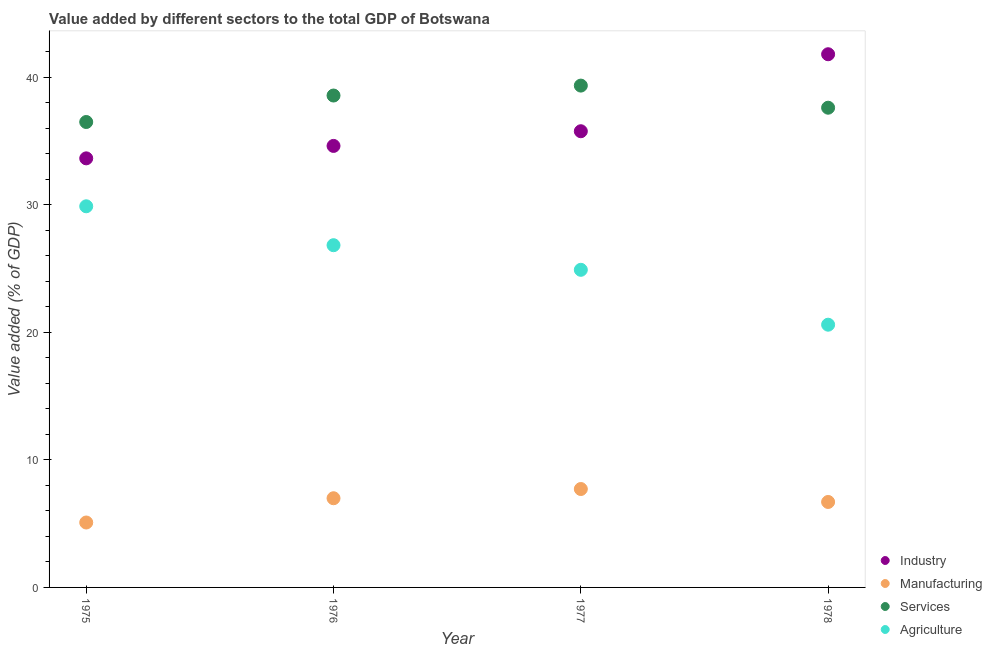How many different coloured dotlines are there?
Keep it short and to the point. 4. What is the value added by services sector in 1976?
Your answer should be compact. 38.56. Across all years, what is the maximum value added by industrial sector?
Provide a short and direct response. 41.8. Across all years, what is the minimum value added by manufacturing sector?
Provide a short and direct response. 5.09. In which year was the value added by industrial sector maximum?
Give a very brief answer. 1978. In which year was the value added by agricultural sector minimum?
Keep it short and to the point. 1978. What is the total value added by industrial sector in the graph?
Your answer should be very brief. 145.81. What is the difference between the value added by manufacturing sector in 1977 and that in 1978?
Keep it short and to the point. 1.01. What is the difference between the value added by services sector in 1975 and the value added by manufacturing sector in 1977?
Give a very brief answer. 28.77. What is the average value added by manufacturing sector per year?
Make the answer very short. 6.62. In the year 1975, what is the difference between the value added by services sector and value added by manufacturing sector?
Your answer should be compact. 31.4. In how many years, is the value added by agricultural sector greater than 22 %?
Ensure brevity in your answer.  3. What is the ratio of the value added by services sector in 1975 to that in 1977?
Your answer should be very brief. 0.93. Is the value added by industrial sector in 1975 less than that in 1977?
Make the answer very short. Yes. What is the difference between the highest and the second highest value added by manufacturing sector?
Provide a succinct answer. 0.72. What is the difference between the highest and the lowest value added by services sector?
Keep it short and to the point. 2.85. Is the sum of the value added by manufacturing sector in 1975 and 1977 greater than the maximum value added by industrial sector across all years?
Offer a very short reply. No. Is it the case that in every year, the sum of the value added by industrial sector and value added by services sector is greater than the sum of value added by manufacturing sector and value added by agricultural sector?
Your answer should be very brief. No. Is it the case that in every year, the sum of the value added by industrial sector and value added by manufacturing sector is greater than the value added by services sector?
Offer a terse response. Yes. Does the value added by services sector monotonically increase over the years?
Provide a succinct answer. No. Is the value added by industrial sector strictly greater than the value added by agricultural sector over the years?
Give a very brief answer. Yes. Is the value added by manufacturing sector strictly less than the value added by services sector over the years?
Keep it short and to the point. Yes. Are the values on the major ticks of Y-axis written in scientific E-notation?
Your answer should be very brief. No. Does the graph contain any zero values?
Your response must be concise. No. How many legend labels are there?
Keep it short and to the point. 4. How are the legend labels stacked?
Offer a terse response. Vertical. What is the title of the graph?
Ensure brevity in your answer.  Value added by different sectors to the total GDP of Botswana. Does "Coal" appear as one of the legend labels in the graph?
Give a very brief answer. No. What is the label or title of the X-axis?
Give a very brief answer. Year. What is the label or title of the Y-axis?
Offer a very short reply. Value added (% of GDP). What is the Value added (% of GDP) of Industry in 1975?
Provide a succinct answer. 33.64. What is the Value added (% of GDP) in Manufacturing in 1975?
Your answer should be compact. 5.09. What is the Value added (% of GDP) in Services in 1975?
Your answer should be very brief. 36.49. What is the Value added (% of GDP) of Agriculture in 1975?
Offer a terse response. 29.88. What is the Value added (% of GDP) in Industry in 1976?
Give a very brief answer. 34.61. What is the Value added (% of GDP) in Manufacturing in 1976?
Ensure brevity in your answer.  6.99. What is the Value added (% of GDP) in Services in 1976?
Make the answer very short. 38.56. What is the Value added (% of GDP) of Agriculture in 1976?
Offer a very short reply. 26.83. What is the Value added (% of GDP) of Industry in 1977?
Keep it short and to the point. 35.76. What is the Value added (% of GDP) in Manufacturing in 1977?
Give a very brief answer. 7.71. What is the Value added (% of GDP) in Services in 1977?
Give a very brief answer. 39.34. What is the Value added (% of GDP) in Agriculture in 1977?
Ensure brevity in your answer.  24.9. What is the Value added (% of GDP) in Industry in 1978?
Your answer should be compact. 41.8. What is the Value added (% of GDP) of Manufacturing in 1978?
Provide a succinct answer. 6.7. What is the Value added (% of GDP) of Services in 1978?
Your response must be concise. 37.61. What is the Value added (% of GDP) in Agriculture in 1978?
Provide a succinct answer. 20.6. Across all years, what is the maximum Value added (% of GDP) of Industry?
Your answer should be very brief. 41.8. Across all years, what is the maximum Value added (% of GDP) of Manufacturing?
Your answer should be very brief. 7.71. Across all years, what is the maximum Value added (% of GDP) in Services?
Make the answer very short. 39.34. Across all years, what is the maximum Value added (% of GDP) of Agriculture?
Give a very brief answer. 29.88. Across all years, what is the minimum Value added (% of GDP) in Industry?
Your answer should be compact. 33.64. Across all years, what is the minimum Value added (% of GDP) in Manufacturing?
Your answer should be very brief. 5.09. Across all years, what is the minimum Value added (% of GDP) of Services?
Keep it short and to the point. 36.49. Across all years, what is the minimum Value added (% of GDP) in Agriculture?
Give a very brief answer. 20.6. What is the total Value added (% of GDP) in Industry in the graph?
Keep it short and to the point. 145.81. What is the total Value added (% of GDP) in Manufacturing in the graph?
Your response must be concise. 26.49. What is the total Value added (% of GDP) in Services in the graph?
Offer a terse response. 151.99. What is the total Value added (% of GDP) of Agriculture in the graph?
Offer a very short reply. 102.2. What is the difference between the Value added (% of GDP) in Industry in 1975 and that in 1976?
Offer a terse response. -0.97. What is the difference between the Value added (% of GDP) of Manufacturing in 1975 and that in 1976?
Provide a succinct answer. -1.9. What is the difference between the Value added (% of GDP) of Services in 1975 and that in 1976?
Ensure brevity in your answer.  -2.08. What is the difference between the Value added (% of GDP) in Agriculture in 1975 and that in 1976?
Make the answer very short. 3.05. What is the difference between the Value added (% of GDP) of Industry in 1975 and that in 1977?
Offer a terse response. -2.13. What is the difference between the Value added (% of GDP) of Manufacturing in 1975 and that in 1977?
Your response must be concise. -2.63. What is the difference between the Value added (% of GDP) in Services in 1975 and that in 1977?
Provide a succinct answer. -2.85. What is the difference between the Value added (% of GDP) in Agriculture in 1975 and that in 1977?
Ensure brevity in your answer.  4.98. What is the difference between the Value added (% of GDP) in Industry in 1975 and that in 1978?
Make the answer very short. -8.16. What is the difference between the Value added (% of GDP) in Manufacturing in 1975 and that in 1978?
Keep it short and to the point. -1.61. What is the difference between the Value added (% of GDP) in Services in 1975 and that in 1978?
Offer a terse response. -1.12. What is the difference between the Value added (% of GDP) of Agriculture in 1975 and that in 1978?
Offer a very short reply. 9.28. What is the difference between the Value added (% of GDP) in Industry in 1976 and that in 1977?
Make the answer very short. -1.15. What is the difference between the Value added (% of GDP) of Manufacturing in 1976 and that in 1977?
Provide a short and direct response. -0.72. What is the difference between the Value added (% of GDP) of Services in 1976 and that in 1977?
Make the answer very short. -0.78. What is the difference between the Value added (% of GDP) of Agriculture in 1976 and that in 1977?
Provide a short and direct response. 1.93. What is the difference between the Value added (% of GDP) of Industry in 1976 and that in 1978?
Your answer should be compact. -7.19. What is the difference between the Value added (% of GDP) of Manufacturing in 1976 and that in 1978?
Give a very brief answer. 0.29. What is the difference between the Value added (% of GDP) of Services in 1976 and that in 1978?
Ensure brevity in your answer.  0.96. What is the difference between the Value added (% of GDP) of Agriculture in 1976 and that in 1978?
Make the answer very short. 6.23. What is the difference between the Value added (% of GDP) in Industry in 1977 and that in 1978?
Provide a succinct answer. -6.04. What is the difference between the Value added (% of GDP) of Manufacturing in 1977 and that in 1978?
Offer a terse response. 1.01. What is the difference between the Value added (% of GDP) in Services in 1977 and that in 1978?
Offer a terse response. 1.73. What is the difference between the Value added (% of GDP) in Agriculture in 1977 and that in 1978?
Your response must be concise. 4.3. What is the difference between the Value added (% of GDP) of Industry in 1975 and the Value added (% of GDP) of Manufacturing in 1976?
Offer a very short reply. 26.64. What is the difference between the Value added (% of GDP) in Industry in 1975 and the Value added (% of GDP) in Services in 1976?
Offer a very short reply. -4.92. What is the difference between the Value added (% of GDP) in Industry in 1975 and the Value added (% of GDP) in Agriculture in 1976?
Keep it short and to the point. 6.81. What is the difference between the Value added (% of GDP) in Manufacturing in 1975 and the Value added (% of GDP) in Services in 1976?
Your response must be concise. -33.47. What is the difference between the Value added (% of GDP) in Manufacturing in 1975 and the Value added (% of GDP) in Agriculture in 1976?
Make the answer very short. -21.74. What is the difference between the Value added (% of GDP) in Services in 1975 and the Value added (% of GDP) in Agriculture in 1976?
Provide a short and direct response. 9.66. What is the difference between the Value added (% of GDP) in Industry in 1975 and the Value added (% of GDP) in Manufacturing in 1977?
Your response must be concise. 25.92. What is the difference between the Value added (% of GDP) in Industry in 1975 and the Value added (% of GDP) in Services in 1977?
Provide a short and direct response. -5.7. What is the difference between the Value added (% of GDP) in Industry in 1975 and the Value added (% of GDP) in Agriculture in 1977?
Offer a terse response. 8.74. What is the difference between the Value added (% of GDP) of Manufacturing in 1975 and the Value added (% of GDP) of Services in 1977?
Keep it short and to the point. -34.25. What is the difference between the Value added (% of GDP) of Manufacturing in 1975 and the Value added (% of GDP) of Agriculture in 1977?
Provide a short and direct response. -19.81. What is the difference between the Value added (% of GDP) in Services in 1975 and the Value added (% of GDP) in Agriculture in 1977?
Give a very brief answer. 11.59. What is the difference between the Value added (% of GDP) in Industry in 1975 and the Value added (% of GDP) in Manufacturing in 1978?
Your answer should be very brief. 26.94. What is the difference between the Value added (% of GDP) of Industry in 1975 and the Value added (% of GDP) of Services in 1978?
Offer a terse response. -3.97. What is the difference between the Value added (% of GDP) of Industry in 1975 and the Value added (% of GDP) of Agriculture in 1978?
Provide a succinct answer. 13.04. What is the difference between the Value added (% of GDP) of Manufacturing in 1975 and the Value added (% of GDP) of Services in 1978?
Offer a very short reply. -32.52. What is the difference between the Value added (% of GDP) in Manufacturing in 1975 and the Value added (% of GDP) in Agriculture in 1978?
Offer a terse response. -15.51. What is the difference between the Value added (% of GDP) of Services in 1975 and the Value added (% of GDP) of Agriculture in 1978?
Your answer should be compact. 15.89. What is the difference between the Value added (% of GDP) of Industry in 1976 and the Value added (% of GDP) of Manufacturing in 1977?
Offer a very short reply. 26.9. What is the difference between the Value added (% of GDP) of Industry in 1976 and the Value added (% of GDP) of Services in 1977?
Your answer should be compact. -4.73. What is the difference between the Value added (% of GDP) in Industry in 1976 and the Value added (% of GDP) in Agriculture in 1977?
Keep it short and to the point. 9.71. What is the difference between the Value added (% of GDP) in Manufacturing in 1976 and the Value added (% of GDP) in Services in 1977?
Your response must be concise. -32.35. What is the difference between the Value added (% of GDP) in Manufacturing in 1976 and the Value added (% of GDP) in Agriculture in 1977?
Provide a succinct answer. -17.91. What is the difference between the Value added (% of GDP) of Services in 1976 and the Value added (% of GDP) of Agriculture in 1977?
Your answer should be compact. 13.66. What is the difference between the Value added (% of GDP) of Industry in 1976 and the Value added (% of GDP) of Manufacturing in 1978?
Give a very brief answer. 27.91. What is the difference between the Value added (% of GDP) in Industry in 1976 and the Value added (% of GDP) in Services in 1978?
Give a very brief answer. -2.99. What is the difference between the Value added (% of GDP) in Industry in 1976 and the Value added (% of GDP) in Agriculture in 1978?
Your answer should be compact. 14.01. What is the difference between the Value added (% of GDP) of Manufacturing in 1976 and the Value added (% of GDP) of Services in 1978?
Give a very brief answer. -30.61. What is the difference between the Value added (% of GDP) in Manufacturing in 1976 and the Value added (% of GDP) in Agriculture in 1978?
Provide a succinct answer. -13.6. What is the difference between the Value added (% of GDP) of Services in 1976 and the Value added (% of GDP) of Agriculture in 1978?
Your answer should be compact. 17.96. What is the difference between the Value added (% of GDP) of Industry in 1977 and the Value added (% of GDP) of Manufacturing in 1978?
Offer a very short reply. 29.06. What is the difference between the Value added (% of GDP) of Industry in 1977 and the Value added (% of GDP) of Services in 1978?
Provide a succinct answer. -1.84. What is the difference between the Value added (% of GDP) in Industry in 1977 and the Value added (% of GDP) in Agriculture in 1978?
Keep it short and to the point. 15.17. What is the difference between the Value added (% of GDP) in Manufacturing in 1977 and the Value added (% of GDP) in Services in 1978?
Your answer should be very brief. -29.89. What is the difference between the Value added (% of GDP) in Manufacturing in 1977 and the Value added (% of GDP) in Agriculture in 1978?
Your answer should be very brief. -12.88. What is the difference between the Value added (% of GDP) of Services in 1977 and the Value added (% of GDP) of Agriculture in 1978?
Keep it short and to the point. 18.74. What is the average Value added (% of GDP) in Industry per year?
Your response must be concise. 36.45. What is the average Value added (% of GDP) in Manufacturing per year?
Your answer should be very brief. 6.62. What is the average Value added (% of GDP) in Services per year?
Make the answer very short. 38. What is the average Value added (% of GDP) of Agriculture per year?
Keep it short and to the point. 25.55. In the year 1975, what is the difference between the Value added (% of GDP) in Industry and Value added (% of GDP) in Manufacturing?
Your response must be concise. 28.55. In the year 1975, what is the difference between the Value added (% of GDP) in Industry and Value added (% of GDP) in Services?
Offer a very short reply. -2.85. In the year 1975, what is the difference between the Value added (% of GDP) in Industry and Value added (% of GDP) in Agriculture?
Provide a short and direct response. 3.76. In the year 1975, what is the difference between the Value added (% of GDP) of Manufacturing and Value added (% of GDP) of Services?
Offer a terse response. -31.4. In the year 1975, what is the difference between the Value added (% of GDP) in Manufacturing and Value added (% of GDP) in Agriculture?
Provide a short and direct response. -24.79. In the year 1975, what is the difference between the Value added (% of GDP) of Services and Value added (% of GDP) of Agriculture?
Provide a short and direct response. 6.61. In the year 1976, what is the difference between the Value added (% of GDP) of Industry and Value added (% of GDP) of Manufacturing?
Offer a very short reply. 27.62. In the year 1976, what is the difference between the Value added (% of GDP) of Industry and Value added (% of GDP) of Services?
Ensure brevity in your answer.  -3.95. In the year 1976, what is the difference between the Value added (% of GDP) of Industry and Value added (% of GDP) of Agriculture?
Keep it short and to the point. 7.78. In the year 1976, what is the difference between the Value added (% of GDP) in Manufacturing and Value added (% of GDP) in Services?
Keep it short and to the point. -31.57. In the year 1976, what is the difference between the Value added (% of GDP) in Manufacturing and Value added (% of GDP) in Agriculture?
Provide a succinct answer. -19.84. In the year 1976, what is the difference between the Value added (% of GDP) of Services and Value added (% of GDP) of Agriculture?
Give a very brief answer. 11.73. In the year 1977, what is the difference between the Value added (% of GDP) of Industry and Value added (% of GDP) of Manufacturing?
Keep it short and to the point. 28.05. In the year 1977, what is the difference between the Value added (% of GDP) of Industry and Value added (% of GDP) of Services?
Your response must be concise. -3.58. In the year 1977, what is the difference between the Value added (% of GDP) in Industry and Value added (% of GDP) in Agriculture?
Give a very brief answer. 10.86. In the year 1977, what is the difference between the Value added (% of GDP) of Manufacturing and Value added (% of GDP) of Services?
Give a very brief answer. -31.62. In the year 1977, what is the difference between the Value added (% of GDP) in Manufacturing and Value added (% of GDP) in Agriculture?
Provide a succinct answer. -17.18. In the year 1977, what is the difference between the Value added (% of GDP) of Services and Value added (% of GDP) of Agriculture?
Offer a terse response. 14.44. In the year 1978, what is the difference between the Value added (% of GDP) in Industry and Value added (% of GDP) in Manufacturing?
Give a very brief answer. 35.1. In the year 1978, what is the difference between the Value added (% of GDP) of Industry and Value added (% of GDP) of Services?
Give a very brief answer. 4.19. In the year 1978, what is the difference between the Value added (% of GDP) in Industry and Value added (% of GDP) in Agriculture?
Your answer should be compact. 21.2. In the year 1978, what is the difference between the Value added (% of GDP) in Manufacturing and Value added (% of GDP) in Services?
Offer a terse response. -30.91. In the year 1978, what is the difference between the Value added (% of GDP) of Manufacturing and Value added (% of GDP) of Agriculture?
Make the answer very short. -13.9. In the year 1978, what is the difference between the Value added (% of GDP) in Services and Value added (% of GDP) in Agriculture?
Give a very brief answer. 17.01. What is the ratio of the Value added (% of GDP) of Industry in 1975 to that in 1976?
Your answer should be very brief. 0.97. What is the ratio of the Value added (% of GDP) in Manufacturing in 1975 to that in 1976?
Keep it short and to the point. 0.73. What is the ratio of the Value added (% of GDP) of Services in 1975 to that in 1976?
Offer a very short reply. 0.95. What is the ratio of the Value added (% of GDP) of Agriculture in 1975 to that in 1976?
Offer a very short reply. 1.11. What is the ratio of the Value added (% of GDP) of Industry in 1975 to that in 1977?
Offer a terse response. 0.94. What is the ratio of the Value added (% of GDP) of Manufacturing in 1975 to that in 1977?
Your response must be concise. 0.66. What is the ratio of the Value added (% of GDP) in Services in 1975 to that in 1977?
Offer a very short reply. 0.93. What is the ratio of the Value added (% of GDP) in Industry in 1975 to that in 1978?
Your answer should be very brief. 0.8. What is the ratio of the Value added (% of GDP) of Manufacturing in 1975 to that in 1978?
Give a very brief answer. 0.76. What is the ratio of the Value added (% of GDP) in Services in 1975 to that in 1978?
Give a very brief answer. 0.97. What is the ratio of the Value added (% of GDP) in Agriculture in 1975 to that in 1978?
Your answer should be compact. 1.45. What is the ratio of the Value added (% of GDP) of Industry in 1976 to that in 1977?
Give a very brief answer. 0.97. What is the ratio of the Value added (% of GDP) of Manufacturing in 1976 to that in 1977?
Your response must be concise. 0.91. What is the ratio of the Value added (% of GDP) in Services in 1976 to that in 1977?
Ensure brevity in your answer.  0.98. What is the ratio of the Value added (% of GDP) in Agriculture in 1976 to that in 1977?
Keep it short and to the point. 1.08. What is the ratio of the Value added (% of GDP) in Industry in 1976 to that in 1978?
Make the answer very short. 0.83. What is the ratio of the Value added (% of GDP) of Manufacturing in 1976 to that in 1978?
Ensure brevity in your answer.  1.04. What is the ratio of the Value added (% of GDP) of Services in 1976 to that in 1978?
Give a very brief answer. 1.03. What is the ratio of the Value added (% of GDP) in Agriculture in 1976 to that in 1978?
Your answer should be compact. 1.3. What is the ratio of the Value added (% of GDP) of Industry in 1977 to that in 1978?
Make the answer very short. 0.86. What is the ratio of the Value added (% of GDP) of Manufacturing in 1977 to that in 1978?
Offer a terse response. 1.15. What is the ratio of the Value added (% of GDP) of Services in 1977 to that in 1978?
Your response must be concise. 1.05. What is the ratio of the Value added (% of GDP) in Agriculture in 1977 to that in 1978?
Offer a very short reply. 1.21. What is the difference between the highest and the second highest Value added (% of GDP) in Industry?
Keep it short and to the point. 6.04. What is the difference between the highest and the second highest Value added (% of GDP) of Manufacturing?
Your answer should be very brief. 0.72. What is the difference between the highest and the second highest Value added (% of GDP) in Services?
Your answer should be very brief. 0.78. What is the difference between the highest and the second highest Value added (% of GDP) in Agriculture?
Your answer should be compact. 3.05. What is the difference between the highest and the lowest Value added (% of GDP) of Industry?
Your answer should be compact. 8.16. What is the difference between the highest and the lowest Value added (% of GDP) in Manufacturing?
Ensure brevity in your answer.  2.63. What is the difference between the highest and the lowest Value added (% of GDP) in Services?
Offer a very short reply. 2.85. What is the difference between the highest and the lowest Value added (% of GDP) of Agriculture?
Your answer should be compact. 9.28. 